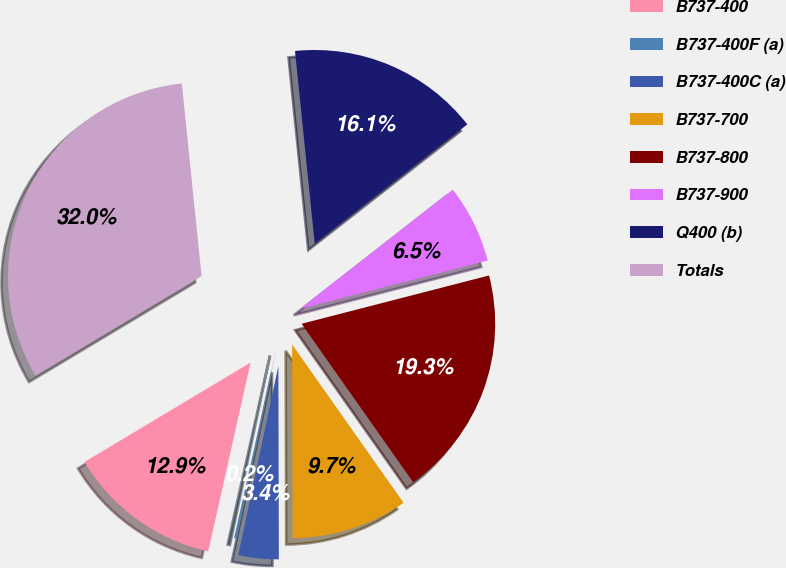Convert chart to OTSL. <chart><loc_0><loc_0><loc_500><loc_500><pie_chart><fcel>B737-400<fcel>B737-400F (a)<fcel>B737-400C (a)<fcel>B737-700<fcel>B737-800<fcel>B737-900<fcel>Q400 (b)<fcel>Totals<nl><fcel>12.9%<fcel>0.19%<fcel>3.36%<fcel>9.72%<fcel>19.25%<fcel>6.54%<fcel>16.07%<fcel>31.96%<nl></chart> 